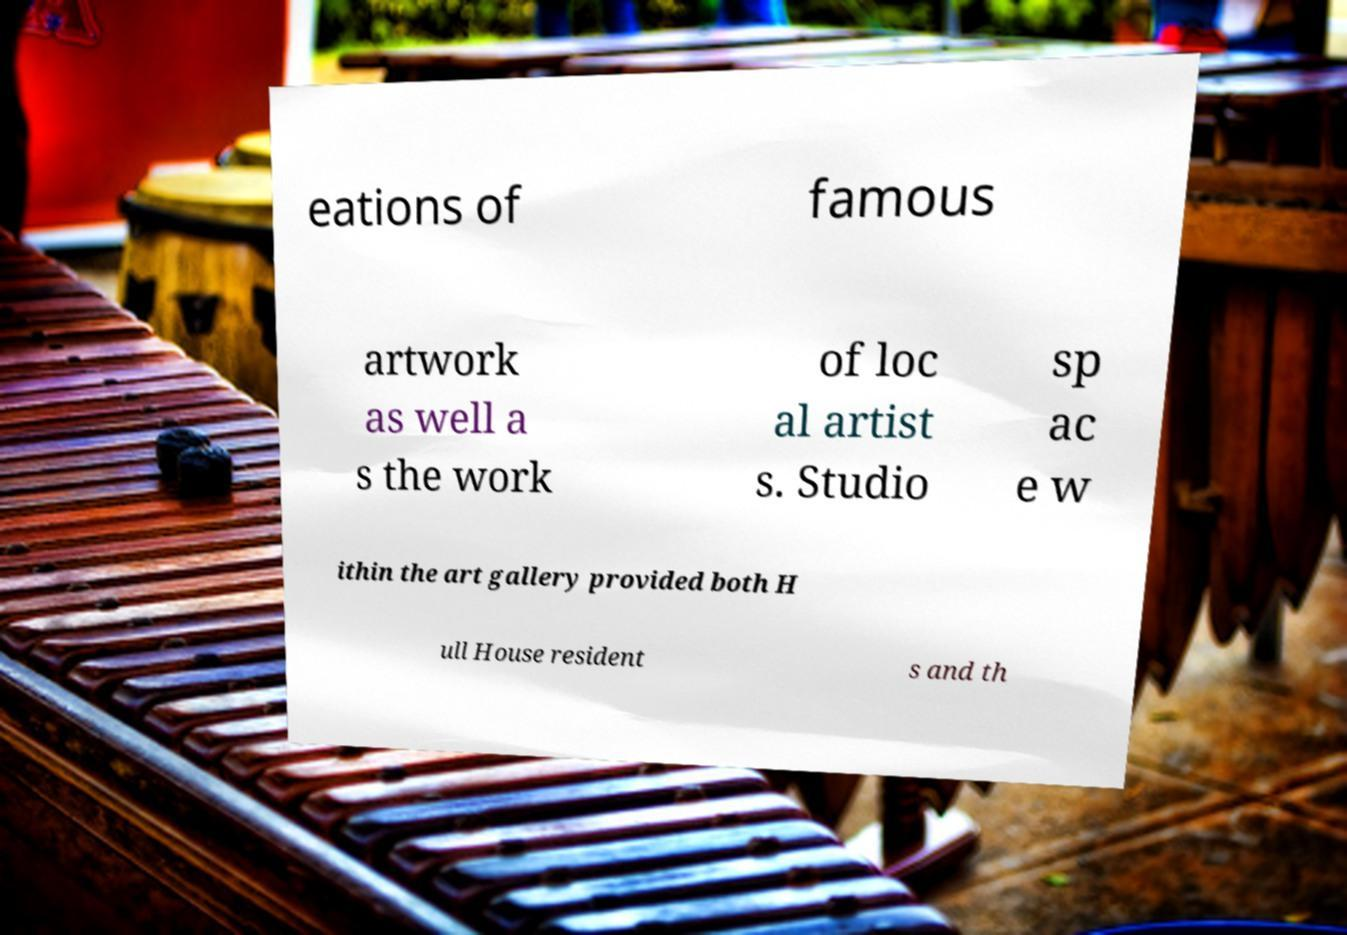Could you assist in decoding the text presented in this image and type it out clearly? eations of famous artwork as well a s the work of loc al artist s. Studio sp ac e w ithin the art gallery provided both H ull House resident s and th 